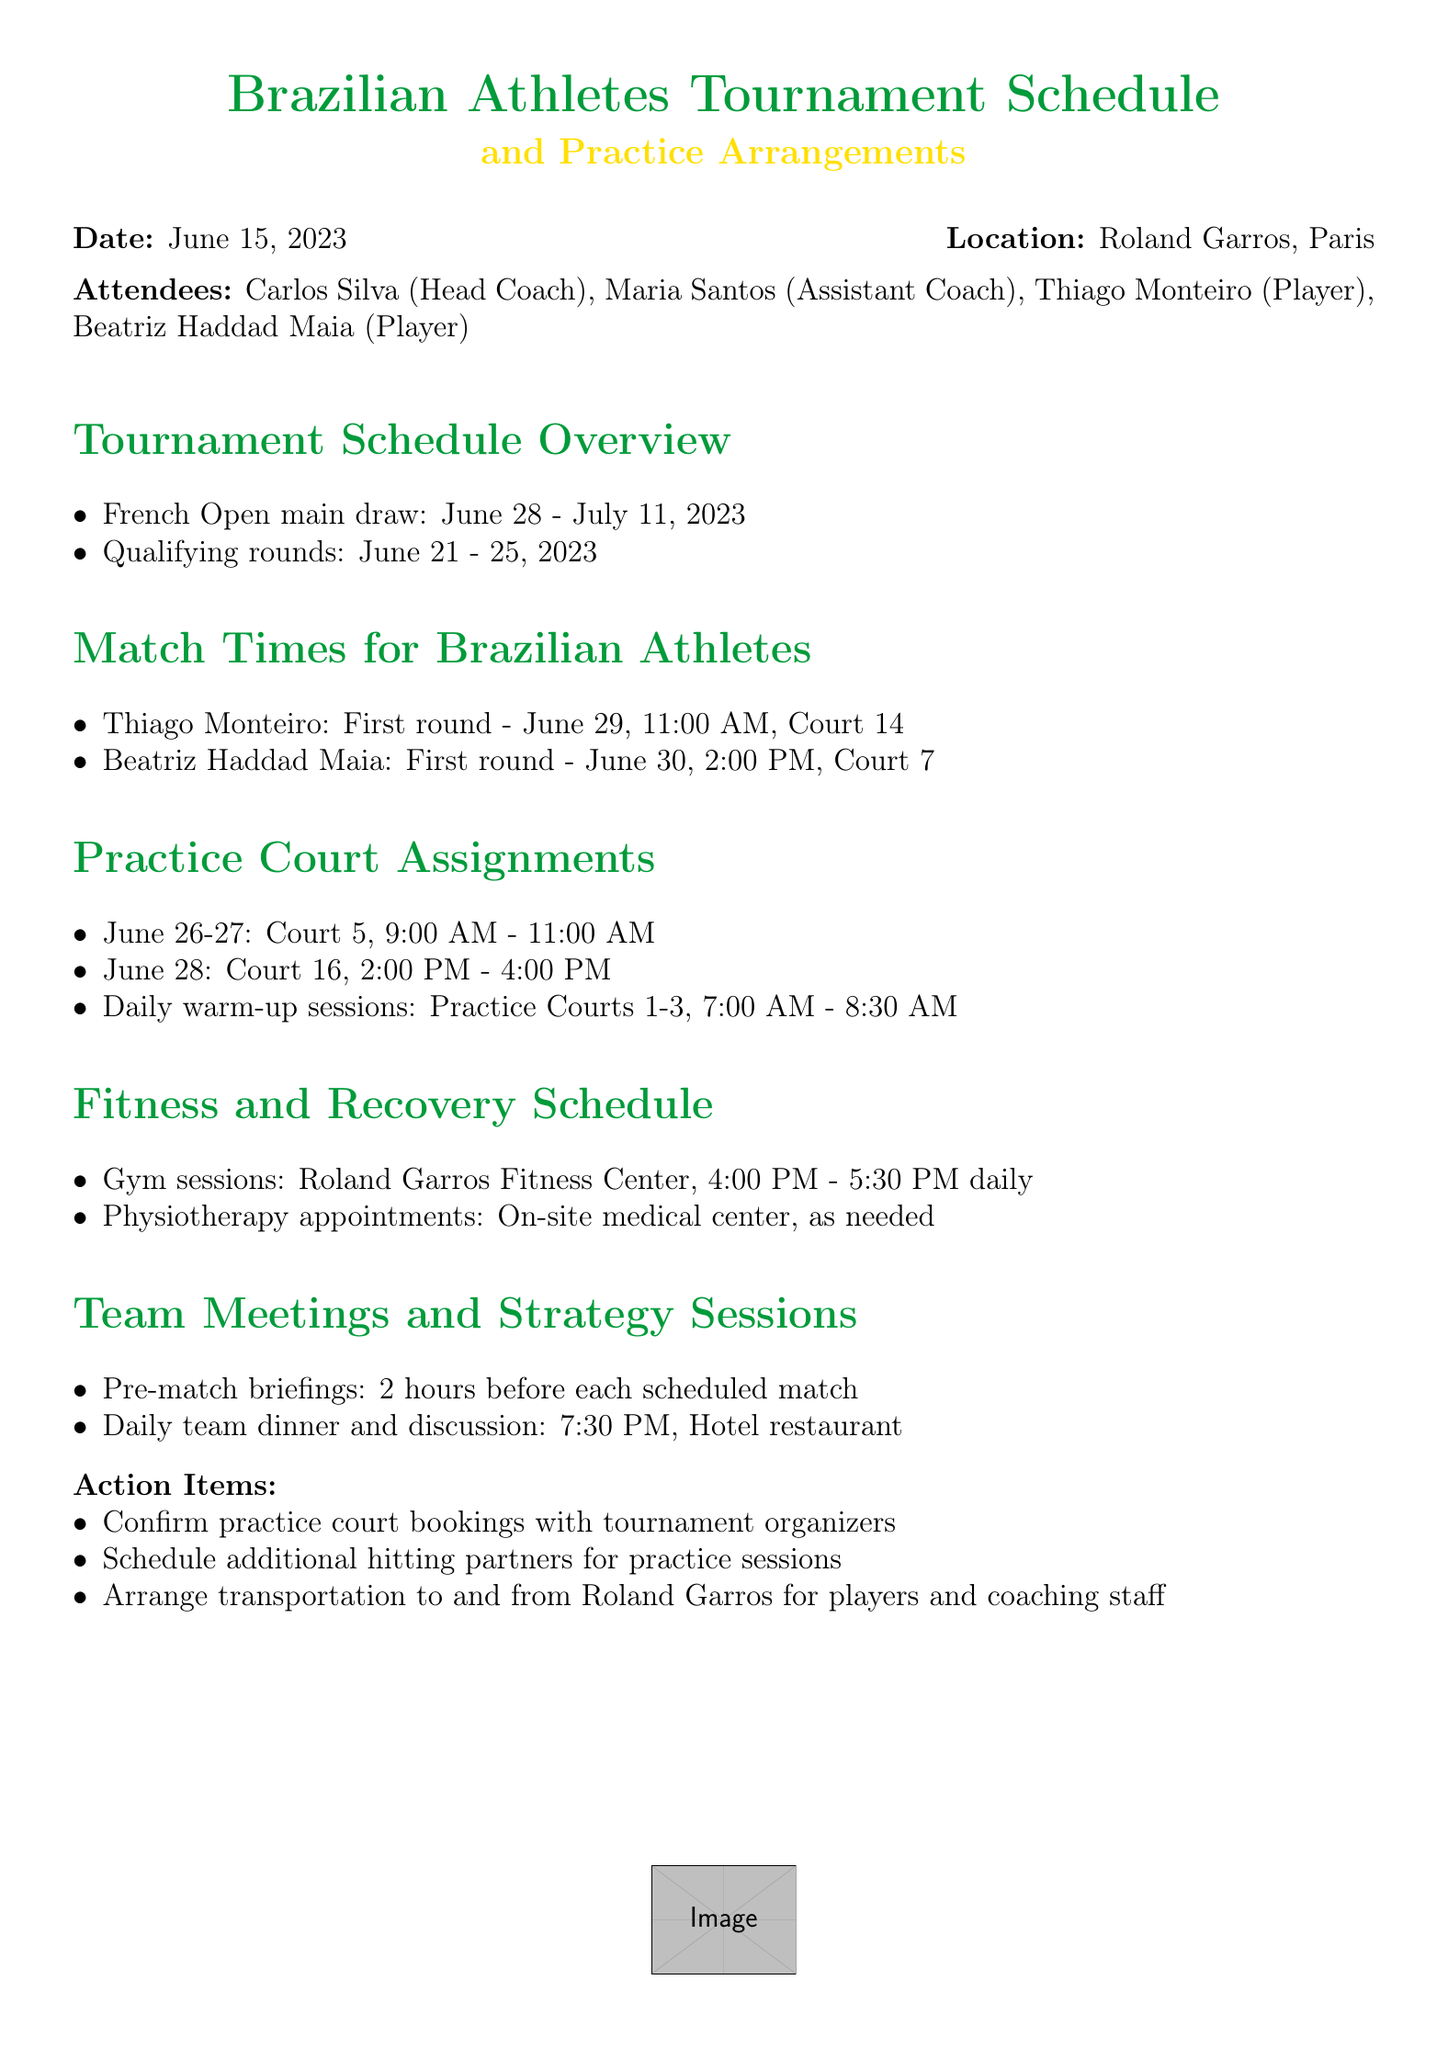What is the date of the meeting? The date is mentioned clearly at the beginning of the document.
Answer: June 15, 2023 Who is the head coach? The head coach is listed among the attendees in the document.
Answer: Carlos Silva When does the French Open main draw start? The start date is provided in the tournament schedule overview.
Answer: June 28, 2023 What time is Thiago Monteiro's first round match? The details of Thiago Monteiro's match time are included in the match times section.
Answer: 11:00 AM Which court is Beatriz Haddad Maia playing on for her first match? The specific court for Beatriz's match is indicated in the document.
Answer: Court 7 How long are the daily warm-up sessions? The duration is explained in the practice court assignments.
Answer: 1 hour 30 minutes What is the timing for team dinners? The timing for daily team dinners is mentioned in the team meetings section.
Answer: 7:30 PM What are the gym session hours? Gym session hours are provided in the fitness and recovery schedule.
Answer: 4:00 PM - 5:30 PM What is the action item regarding practice court bookings? An action item list is provided at the end of the document which includes this information.
Answer: Confirm practice court bookings with tournament organizers 